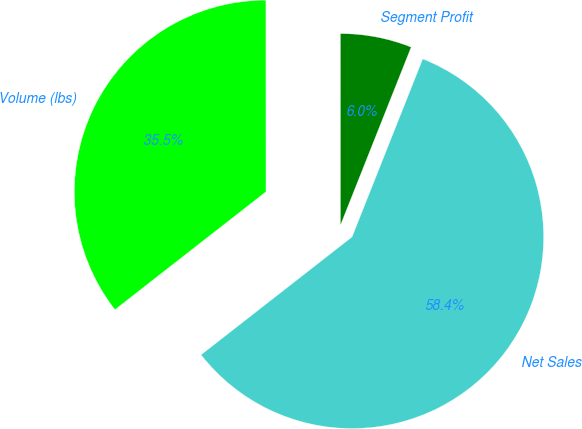<chart> <loc_0><loc_0><loc_500><loc_500><pie_chart><fcel>Volume (lbs)<fcel>Net Sales<fcel>Segment Profit<nl><fcel>35.55%<fcel>58.44%<fcel>6.02%<nl></chart> 